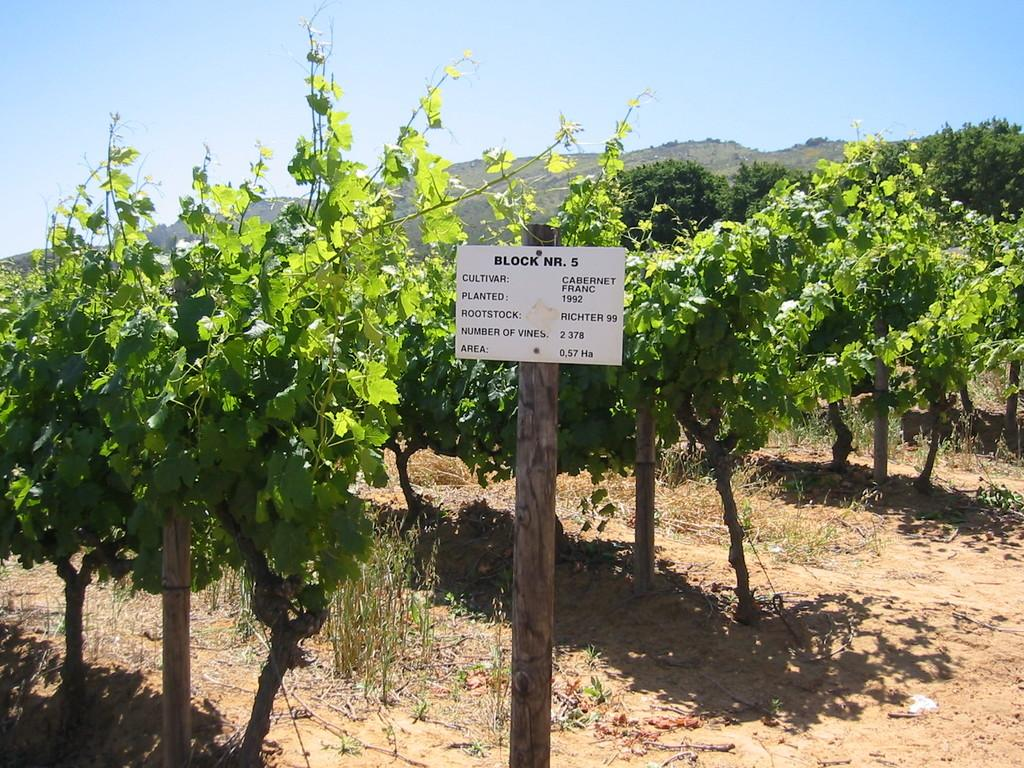What is the main feature of the image? There are many plants in the image. What else can be seen in the image besides plants? There is a pole with a board in the image, and mountains are visible in the image. What is written on the board? There is text on the board. How would you describe the weather in the image? The sky is clear in the image, suggesting good weather. How many members are on the committee seen in the image? There is no committee present in the image. What type of trail can be seen winding through the mountains in the image? There is no trail visible in the image; only plants, a pole with a board, mountains, and the clear sky are present. 